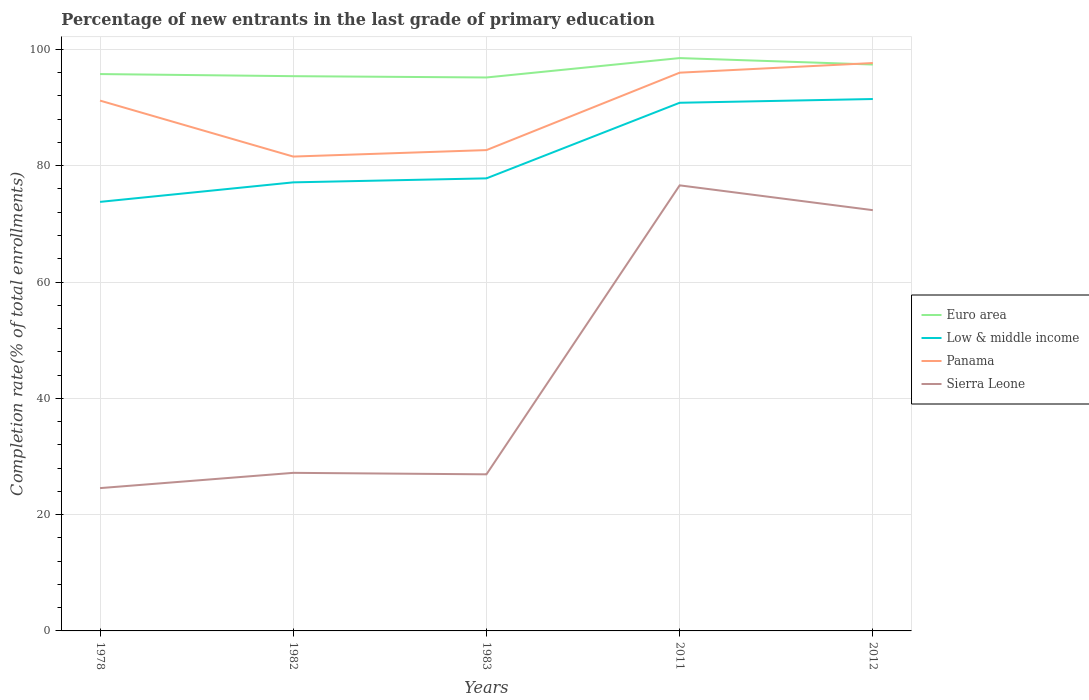Does the line corresponding to Euro area intersect with the line corresponding to Panama?
Your answer should be compact. Yes. Is the number of lines equal to the number of legend labels?
Your response must be concise. Yes. Across all years, what is the maximum percentage of new entrants in Low & middle income?
Offer a terse response. 73.78. What is the total percentage of new entrants in Panama in the graph?
Give a very brief answer. -1.11. What is the difference between the highest and the second highest percentage of new entrants in Euro area?
Give a very brief answer. 3.33. Is the percentage of new entrants in Panama strictly greater than the percentage of new entrants in Euro area over the years?
Offer a very short reply. No. How many years are there in the graph?
Your answer should be very brief. 5. Does the graph contain any zero values?
Your answer should be compact. No. Does the graph contain grids?
Offer a terse response. Yes. What is the title of the graph?
Your answer should be compact. Percentage of new entrants in the last grade of primary education. Does "Congo (Republic)" appear as one of the legend labels in the graph?
Give a very brief answer. No. What is the label or title of the Y-axis?
Make the answer very short. Completion rate(% of total enrollments). What is the Completion rate(% of total enrollments) of Euro area in 1978?
Provide a short and direct response. 95.76. What is the Completion rate(% of total enrollments) of Low & middle income in 1978?
Make the answer very short. 73.78. What is the Completion rate(% of total enrollments) in Panama in 1978?
Your answer should be very brief. 91.2. What is the Completion rate(% of total enrollments) of Sierra Leone in 1978?
Make the answer very short. 24.56. What is the Completion rate(% of total enrollments) of Euro area in 1982?
Keep it short and to the point. 95.4. What is the Completion rate(% of total enrollments) of Low & middle income in 1982?
Keep it short and to the point. 77.14. What is the Completion rate(% of total enrollments) in Panama in 1982?
Provide a short and direct response. 81.57. What is the Completion rate(% of total enrollments) of Sierra Leone in 1982?
Your response must be concise. 27.18. What is the Completion rate(% of total enrollments) of Euro area in 1983?
Ensure brevity in your answer.  95.17. What is the Completion rate(% of total enrollments) of Low & middle income in 1983?
Your response must be concise. 77.83. What is the Completion rate(% of total enrollments) in Panama in 1983?
Keep it short and to the point. 82.69. What is the Completion rate(% of total enrollments) in Sierra Leone in 1983?
Your answer should be very brief. 26.93. What is the Completion rate(% of total enrollments) in Euro area in 2011?
Give a very brief answer. 98.51. What is the Completion rate(% of total enrollments) in Low & middle income in 2011?
Make the answer very short. 90.82. What is the Completion rate(% of total enrollments) of Panama in 2011?
Ensure brevity in your answer.  96. What is the Completion rate(% of total enrollments) in Sierra Leone in 2011?
Your answer should be very brief. 76.62. What is the Completion rate(% of total enrollments) in Euro area in 2012?
Your answer should be very brief. 97.4. What is the Completion rate(% of total enrollments) of Low & middle income in 2012?
Your answer should be very brief. 91.47. What is the Completion rate(% of total enrollments) in Panama in 2012?
Provide a short and direct response. 97.66. What is the Completion rate(% of total enrollments) of Sierra Leone in 2012?
Ensure brevity in your answer.  72.36. Across all years, what is the maximum Completion rate(% of total enrollments) in Euro area?
Offer a very short reply. 98.51. Across all years, what is the maximum Completion rate(% of total enrollments) in Low & middle income?
Offer a terse response. 91.47. Across all years, what is the maximum Completion rate(% of total enrollments) in Panama?
Your answer should be compact. 97.66. Across all years, what is the maximum Completion rate(% of total enrollments) of Sierra Leone?
Give a very brief answer. 76.62. Across all years, what is the minimum Completion rate(% of total enrollments) of Euro area?
Ensure brevity in your answer.  95.17. Across all years, what is the minimum Completion rate(% of total enrollments) of Low & middle income?
Provide a short and direct response. 73.78. Across all years, what is the minimum Completion rate(% of total enrollments) in Panama?
Offer a terse response. 81.57. Across all years, what is the minimum Completion rate(% of total enrollments) in Sierra Leone?
Keep it short and to the point. 24.56. What is the total Completion rate(% of total enrollments) of Euro area in the graph?
Your response must be concise. 482.24. What is the total Completion rate(% of total enrollments) of Low & middle income in the graph?
Your answer should be compact. 411.04. What is the total Completion rate(% of total enrollments) of Panama in the graph?
Your answer should be compact. 449.11. What is the total Completion rate(% of total enrollments) in Sierra Leone in the graph?
Provide a succinct answer. 227.65. What is the difference between the Completion rate(% of total enrollments) in Euro area in 1978 and that in 1982?
Provide a succinct answer. 0.36. What is the difference between the Completion rate(% of total enrollments) in Low & middle income in 1978 and that in 1982?
Ensure brevity in your answer.  -3.36. What is the difference between the Completion rate(% of total enrollments) of Panama in 1978 and that in 1982?
Ensure brevity in your answer.  9.62. What is the difference between the Completion rate(% of total enrollments) of Sierra Leone in 1978 and that in 1982?
Make the answer very short. -2.63. What is the difference between the Completion rate(% of total enrollments) in Euro area in 1978 and that in 1983?
Give a very brief answer. 0.58. What is the difference between the Completion rate(% of total enrollments) in Low & middle income in 1978 and that in 1983?
Keep it short and to the point. -4.04. What is the difference between the Completion rate(% of total enrollments) in Panama in 1978 and that in 1983?
Offer a terse response. 8.51. What is the difference between the Completion rate(% of total enrollments) of Sierra Leone in 1978 and that in 1983?
Provide a short and direct response. -2.37. What is the difference between the Completion rate(% of total enrollments) in Euro area in 1978 and that in 2011?
Your answer should be compact. -2.75. What is the difference between the Completion rate(% of total enrollments) in Low & middle income in 1978 and that in 2011?
Offer a very short reply. -17.04. What is the difference between the Completion rate(% of total enrollments) in Panama in 1978 and that in 2011?
Ensure brevity in your answer.  -4.8. What is the difference between the Completion rate(% of total enrollments) in Sierra Leone in 1978 and that in 2011?
Make the answer very short. -52.06. What is the difference between the Completion rate(% of total enrollments) of Euro area in 1978 and that in 2012?
Your answer should be compact. -1.64. What is the difference between the Completion rate(% of total enrollments) of Low & middle income in 1978 and that in 2012?
Offer a very short reply. -17.69. What is the difference between the Completion rate(% of total enrollments) in Panama in 1978 and that in 2012?
Make the answer very short. -6.46. What is the difference between the Completion rate(% of total enrollments) in Sierra Leone in 1978 and that in 2012?
Your answer should be compact. -47.8. What is the difference between the Completion rate(% of total enrollments) in Euro area in 1982 and that in 1983?
Your response must be concise. 0.22. What is the difference between the Completion rate(% of total enrollments) in Low & middle income in 1982 and that in 1983?
Keep it short and to the point. -0.69. What is the difference between the Completion rate(% of total enrollments) in Panama in 1982 and that in 1983?
Ensure brevity in your answer.  -1.11. What is the difference between the Completion rate(% of total enrollments) in Sierra Leone in 1982 and that in 1983?
Ensure brevity in your answer.  0.26. What is the difference between the Completion rate(% of total enrollments) in Euro area in 1982 and that in 2011?
Your answer should be compact. -3.11. What is the difference between the Completion rate(% of total enrollments) of Low & middle income in 1982 and that in 2011?
Provide a succinct answer. -13.69. What is the difference between the Completion rate(% of total enrollments) of Panama in 1982 and that in 2011?
Your answer should be very brief. -14.43. What is the difference between the Completion rate(% of total enrollments) of Sierra Leone in 1982 and that in 2011?
Your answer should be very brief. -49.44. What is the difference between the Completion rate(% of total enrollments) in Euro area in 1982 and that in 2012?
Keep it short and to the point. -2. What is the difference between the Completion rate(% of total enrollments) in Low & middle income in 1982 and that in 2012?
Your answer should be compact. -14.33. What is the difference between the Completion rate(% of total enrollments) of Panama in 1982 and that in 2012?
Offer a very short reply. -16.08. What is the difference between the Completion rate(% of total enrollments) of Sierra Leone in 1982 and that in 2012?
Make the answer very short. -45.17. What is the difference between the Completion rate(% of total enrollments) in Euro area in 1983 and that in 2011?
Your answer should be compact. -3.33. What is the difference between the Completion rate(% of total enrollments) of Low & middle income in 1983 and that in 2011?
Your answer should be very brief. -13. What is the difference between the Completion rate(% of total enrollments) of Panama in 1983 and that in 2011?
Provide a succinct answer. -13.31. What is the difference between the Completion rate(% of total enrollments) of Sierra Leone in 1983 and that in 2011?
Give a very brief answer. -49.69. What is the difference between the Completion rate(% of total enrollments) in Euro area in 1983 and that in 2012?
Ensure brevity in your answer.  -2.23. What is the difference between the Completion rate(% of total enrollments) in Low & middle income in 1983 and that in 2012?
Your response must be concise. -13.64. What is the difference between the Completion rate(% of total enrollments) of Panama in 1983 and that in 2012?
Give a very brief answer. -14.97. What is the difference between the Completion rate(% of total enrollments) of Sierra Leone in 1983 and that in 2012?
Offer a very short reply. -45.43. What is the difference between the Completion rate(% of total enrollments) in Euro area in 2011 and that in 2012?
Your answer should be compact. 1.11. What is the difference between the Completion rate(% of total enrollments) in Low & middle income in 2011 and that in 2012?
Provide a succinct answer. -0.64. What is the difference between the Completion rate(% of total enrollments) of Panama in 2011 and that in 2012?
Your answer should be very brief. -1.66. What is the difference between the Completion rate(% of total enrollments) in Sierra Leone in 2011 and that in 2012?
Offer a very short reply. 4.27. What is the difference between the Completion rate(% of total enrollments) in Euro area in 1978 and the Completion rate(% of total enrollments) in Low & middle income in 1982?
Your answer should be very brief. 18.62. What is the difference between the Completion rate(% of total enrollments) of Euro area in 1978 and the Completion rate(% of total enrollments) of Panama in 1982?
Ensure brevity in your answer.  14.19. What is the difference between the Completion rate(% of total enrollments) of Euro area in 1978 and the Completion rate(% of total enrollments) of Sierra Leone in 1982?
Your response must be concise. 68.58. What is the difference between the Completion rate(% of total enrollments) in Low & middle income in 1978 and the Completion rate(% of total enrollments) in Panama in 1982?
Ensure brevity in your answer.  -7.79. What is the difference between the Completion rate(% of total enrollments) of Low & middle income in 1978 and the Completion rate(% of total enrollments) of Sierra Leone in 1982?
Your answer should be compact. 46.6. What is the difference between the Completion rate(% of total enrollments) of Panama in 1978 and the Completion rate(% of total enrollments) of Sierra Leone in 1982?
Provide a short and direct response. 64.01. What is the difference between the Completion rate(% of total enrollments) of Euro area in 1978 and the Completion rate(% of total enrollments) of Low & middle income in 1983?
Keep it short and to the point. 17.93. What is the difference between the Completion rate(% of total enrollments) of Euro area in 1978 and the Completion rate(% of total enrollments) of Panama in 1983?
Keep it short and to the point. 13.07. What is the difference between the Completion rate(% of total enrollments) of Euro area in 1978 and the Completion rate(% of total enrollments) of Sierra Leone in 1983?
Keep it short and to the point. 68.83. What is the difference between the Completion rate(% of total enrollments) of Low & middle income in 1978 and the Completion rate(% of total enrollments) of Panama in 1983?
Ensure brevity in your answer.  -8.9. What is the difference between the Completion rate(% of total enrollments) in Low & middle income in 1978 and the Completion rate(% of total enrollments) in Sierra Leone in 1983?
Ensure brevity in your answer.  46.85. What is the difference between the Completion rate(% of total enrollments) of Panama in 1978 and the Completion rate(% of total enrollments) of Sierra Leone in 1983?
Your response must be concise. 64.27. What is the difference between the Completion rate(% of total enrollments) of Euro area in 1978 and the Completion rate(% of total enrollments) of Low & middle income in 2011?
Give a very brief answer. 4.93. What is the difference between the Completion rate(% of total enrollments) in Euro area in 1978 and the Completion rate(% of total enrollments) in Panama in 2011?
Provide a succinct answer. -0.24. What is the difference between the Completion rate(% of total enrollments) in Euro area in 1978 and the Completion rate(% of total enrollments) in Sierra Leone in 2011?
Your response must be concise. 19.14. What is the difference between the Completion rate(% of total enrollments) in Low & middle income in 1978 and the Completion rate(% of total enrollments) in Panama in 2011?
Provide a succinct answer. -22.22. What is the difference between the Completion rate(% of total enrollments) in Low & middle income in 1978 and the Completion rate(% of total enrollments) in Sierra Leone in 2011?
Your answer should be very brief. -2.84. What is the difference between the Completion rate(% of total enrollments) of Panama in 1978 and the Completion rate(% of total enrollments) of Sierra Leone in 2011?
Your response must be concise. 14.57. What is the difference between the Completion rate(% of total enrollments) of Euro area in 1978 and the Completion rate(% of total enrollments) of Low & middle income in 2012?
Provide a short and direct response. 4.29. What is the difference between the Completion rate(% of total enrollments) in Euro area in 1978 and the Completion rate(% of total enrollments) in Panama in 2012?
Offer a terse response. -1.9. What is the difference between the Completion rate(% of total enrollments) of Euro area in 1978 and the Completion rate(% of total enrollments) of Sierra Leone in 2012?
Your response must be concise. 23.4. What is the difference between the Completion rate(% of total enrollments) in Low & middle income in 1978 and the Completion rate(% of total enrollments) in Panama in 2012?
Provide a short and direct response. -23.88. What is the difference between the Completion rate(% of total enrollments) in Low & middle income in 1978 and the Completion rate(% of total enrollments) in Sierra Leone in 2012?
Give a very brief answer. 1.42. What is the difference between the Completion rate(% of total enrollments) of Panama in 1978 and the Completion rate(% of total enrollments) of Sierra Leone in 2012?
Offer a very short reply. 18.84. What is the difference between the Completion rate(% of total enrollments) in Euro area in 1982 and the Completion rate(% of total enrollments) in Low & middle income in 1983?
Give a very brief answer. 17.57. What is the difference between the Completion rate(% of total enrollments) of Euro area in 1982 and the Completion rate(% of total enrollments) of Panama in 1983?
Provide a succinct answer. 12.71. What is the difference between the Completion rate(% of total enrollments) of Euro area in 1982 and the Completion rate(% of total enrollments) of Sierra Leone in 1983?
Offer a very short reply. 68.47. What is the difference between the Completion rate(% of total enrollments) in Low & middle income in 1982 and the Completion rate(% of total enrollments) in Panama in 1983?
Your answer should be very brief. -5.55. What is the difference between the Completion rate(% of total enrollments) in Low & middle income in 1982 and the Completion rate(% of total enrollments) in Sierra Leone in 1983?
Your answer should be compact. 50.21. What is the difference between the Completion rate(% of total enrollments) of Panama in 1982 and the Completion rate(% of total enrollments) of Sierra Leone in 1983?
Your answer should be very brief. 54.64. What is the difference between the Completion rate(% of total enrollments) of Euro area in 1982 and the Completion rate(% of total enrollments) of Low & middle income in 2011?
Keep it short and to the point. 4.57. What is the difference between the Completion rate(% of total enrollments) in Euro area in 1982 and the Completion rate(% of total enrollments) in Panama in 2011?
Offer a very short reply. -0.6. What is the difference between the Completion rate(% of total enrollments) of Euro area in 1982 and the Completion rate(% of total enrollments) of Sierra Leone in 2011?
Your answer should be compact. 18.78. What is the difference between the Completion rate(% of total enrollments) in Low & middle income in 1982 and the Completion rate(% of total enrollments) in Panama in 2011?
Provide a short and direct response. -18.86. What is the difference between the Completion rate(% of total enrollments) in Low & middle income in 1982 and the Completion rate(% of total enrollments) in Sierra Leone in 2011?
Offer a very short reply. 0.52. What is the difference between the Completion rate(% of total enrollments) of Panama in 1982 and the Completion rate(% of total enrollments) of Sierra Leone in 2011?
Make the answer very short. 4.95. What is the difference between the Completion rate(% of total enrollments) of Euro area in 1982 and the Completion rate(% of total enrollments) of Low & middle income in 2012?
Offer a very short reply. 3.93. What is the difference between the Completion rate(% of total enrollments) in Euro area in 1982 and the Completion rate(% of total enrollments) in Panama in 2012?
Your answer should be compact. -2.26. What is the difference between the Completion rate(% of total enrollments) of Euro area in 1982 and the Completion rate(% of total enrollments) of Sierra Leone in 2012?
Your answer should be very brief. 23.04. What is the difference between the Completion rate(% of total enrollments) of Low & middle income in 1982 and the Completion rate(% of total enrollments) of Panama in 2012?
Your answer should be very brief. -20.52. What is the difference between the Completion rate(% of total enrollments) of Low & middle income in 1982 and the Completion rate(% of total enrollments) of Sierra Leone in 2012?
Offer a very short reply. 4.78. What is the difference between the Completion rate(% of total enrollments) of Panama in 1982 and the Completion rate(% of total enrollments) of Sierra Leone in 2012?
Your response must be concise. 9.22. What is the difference between the Completion rate(% of total enrollments) in Euro area in 1983 and the Completion rate(% of total enrollments) in Low & middle income in 2011?
Your response must be concise. 4.35. What is the difference between the Completion rate(% of total enrollments) in Euro area in 1983 and the Completion rate(% of total enrollments) in Panama in 2011?
Ensure brevity in your answer.  -0.82. What is the difference between the Completion rate(% of total enrollments) in Euro area in 1983 and the Completion rate(% of total enrollments) in Sierra Leone in 2011?
Offer a terse response. 18.55. What is the difference between the Completion rate(% of total enrollments) in Low & middle income in 1983 and the Completion rate(% of total enrollments) in Panama in 2011?
Your response must be concise. -18.17. What is the difference between the Completion rate(% of total enrollments) in Low & middle income in 1983 and the Completion rate(% of total enrollments) in Sierra Leone in 2011?
Your response must be concise. 1.2. What is the difference between the Completion rate(% of total enrollments) of Panama in 1983 and the Completion rate(% of total enrollments) of Sierra Leone in 2011?
Keep it short and to the point. 6.06. What is the difference between the Completion rate(% of total enrollments) in Euro area in 1983 and the Completion rate(% of total enrollments) in Low & middle income in 2012?
Keep it short and to the point. 3.71. What is the difference between the Completion rate(% of total enrollments) in Euro area in 1983 and the Completion rate(% of total enrollments) in Panama in 2012?
Your answer should be very brief. -2.48. What is the difference between the Completion rate(% of total enrollments) in Euro area in 1983 and the Completion rate(% of total enrollments) in Sierra Leone in 2012?
Your answer should be very brief. 22.82. What is the difference between the Completion rate(% of total enrollments) of Low & middle income in 1983 and the Completion rate(% of total enrollments) of Panama in 2012?
Offer a very short reply. -19.83. What is the difference between the Completion rate(% of total enrollments) of Low & middle income in 1983 and the Completion rate(% of total enrollments) of Sierra Leone in 2012?
Offer a very short reply. 5.47. What is the difference between the Completion rate(% of total enrollments) of Panama in 1983 and the Completion rate(% of total enrollments) of Sierra Leone in 2012?
Keep it short and to the point. 10.33. What is the difference between the Completion rate(% of total enrollments) of Euro area in 2011 and the Completion rate(% of total enrollments) of Low & middle income in 2012?
Offer a very short reply. 7.04. What is the difference between the Completion rate(% of total enrollments) of Euro area in 2011 and the Completion rate(% of total enrollments) of Panama in 2012?
Offer a terse response. 0.85. What is the difference between the Completion rate(% of total enrollments) of Euro area in 2011 and the Completion rate(% of total enrollments) of Sierra Leone in 2012?
Your response must be concise. 26.15. What is the difference between the Completion rate(% of total enrollments) of Low & middle income in 2011 and the Completion rate(% of total enrollments) of Panama in 2012?
Make the answer very short. -6.83. What is the difference between the Completion rate(% of total enrollments) of Low & middle income in 2011 and the Completion rate(% of total enrollments) of Sierra Leone in 2012?
Offer a very short reply. 18.47. What is the difference between the Completion rate(% of total enrollments) in Panama in 2011 and the Completion rate(% of total enrollments) in Sierra Leone in 2012?
Ensure brevity in your answer.  23.64. What is the average Completion rate(% of total enrollments) in Euro area per year?
Provide a succinct answer. 96.45. What is the average Completion rate(% of total enrollments) of Low & middle income per year?
Provide a succinct answer. 82.21. What is the average Completion rate(% of total enrollments) of Panama per year?
Give a very brief answer. 89.82. What is the average Completion rate(% of total enrollments) of Sierra Leone per year?
Offer a terse response. 45.53. In the year 1978, what is the difference between the Completion rate(% of total enrollments) of Euro area and Completion rate(% of total enrollments) of Low & middle income?
Your answer should be very brief. 21.98. In the year 1978, what is the difference between the Completion rate(% of total enrollments) in Euro area and Completion rate(% of total enrollments) in Panama?
Ensure brevity in your answer.  4.56. In the year 1978, what is the difference between the Completion rate(% of total enrollments) of Euro area and Completion rate(% of total enrollments) of Sierra Leone?
Ensure brevity in your answer.  71.2. In the year 1978, what is the difference between the Completion rate(% of total enrollments) in Low & middle income and Completion rate(% of total enrollments) in Panama?
Provide a short and direct response. -17.42. In the year 1978, what is the difference between the Completion rate(% of total enrollments) in Low & middle income and Completion rate(% of total enrollments) in Sierra Leone?
Offer a very short reply. 49.22. In the year 1978, what is the difference between the Completion rate(% of total enrollments) of Panama and Completion rate(% of total enrollments) of Sierra Leone?
Your answer should be very brief. 66.64. In the year 1982, what is the difference between the Completion rate(% of total enrollments) in Euro area and Completion rate(% of total enrollments) in Low & middle income?
Make the answer very short. 18.26. In the year 1982, what is the difference between the Completion rate(% of total enrollments) in Euro area and Completion rate(% of total enrollments) in Panama?
Provide a short and direct response. 13.83. In the year 1982, what is the difference between the Completion rate(% of total enrollments) in Euro area and Completion rate(% of total enrollments) in Sierra Leone?
Give a very brief answer. 68.21. In the year 1982, what is the difference between the Completion rate(% of total enrollments) of Low & middle income and Completion rate(% of total enrollments) of Panama?
Offer a terse response. -4.44. In the year 1982, what is the difference between the Completion rate(% of total enrollments) in Low & middle income and Completion rate(% of total enrollments) in Sierra Leone?
Ensure brevity in your answer.  49.95. In the year 1982, what is the difference between the Completion rate(% of total enrollments) in Panama and Completion rate(% of total enrollments) in Sierra Leone?
Keep it short and to the point. 54.39. In the year 1983, what is the difference between the Completion rate(% of total enrollments) of Euro area and Completion rate(% of total enrollments) of Low & middle income?
Give a very brief answer. 17.35. In the year 1983, what is the difference between the Completion rate(% of total enrollments) in Euro area and Completion rate(% of total enrollments) in Panama?
Give a very brief answer. 12.49. In the year 1983, what is the difference between the Completion rate(% of total enrollments) of Euro area and Completion rate(% of total enrollments) of Sierra Leone?
Your response must be concise. 68.25. In the year 1983, what is the difference between the Completion rate(% of total enrollments) in Low & middle income and Completion rate(% of total enrollments) in Panama?
Give a very brief answer. -4.86. In the year 1983, what is the difference between the Completion rate(% of total enrollments) of Low & middle income and Completion rate(% of total enrollments) of Sierra Leone?
Your answer should be very brief. 50.9. In the year 1983, what is the difference between the Completion rate(% of total enrollments) in Panama and Completion rate(% of total enrollments) in Sierra Leone?
Your answer should be compact. 55.76. In the year 2011, what is the difference between the Completion rate(% of total enrollments) of Euro area and Completion rate(% of total enrollments) of Low & middle income?
Give a very brief answer. 7.68. In the year 2011, what is the difference between the Completion rate(% of total enrollments) of Euro area and Completion rate(% of total enrollments) of Panama?
Keep it short and to the point. 2.51. In the year 2011, what is the difference between the Completion rate(% of total enrollments) of Euro area and Completion rate(% of total enrollments) of Sierra Leone?
Your response must be concise. 21.89. In the year 2011, what is the difference between the Completion rate(% of total enrollments) of Low & middle income and Completion rate(% of total enrollments) of Panama?
Give a very brief answer. -5.17. In the year 2011, what is the difference between the Completion rate(% of total enrollments) of Low & middle income and Completion rate(% of total enrollments) of Sierra Leone?
Provide a short and direct response. 14.2. In the year 2011, what is the difference between the Completion rate(% of total enrollments) in Panama and Completion rate(% of total enrollments) in Sierra Leone?
Provide a short and direct response. 19.38. In the year 2012, what is the difference between the Completion rate(% of total enrollments) of Euro area and Completion rate(% of total enrollments) of Low & middle income?
Your answer should be very brief. 5.93. In the year 2012, what is the difference between the Completion rate(% of total enrollments) in Euro area and Completion rate(% of total enrollments) in Panama?
Provide a succinct answer. -0.26. In the year 2012, what is the difference between the Completion rate(% of total enrollments) of Euro area and Completion rate(% of total enrollments) of Sierra Leone?
Keep it short and to the point. 25.04. In the year 2012, what is the difference between the Completion rate(% of total enrollments) of Low & middle income and Completion rate(% of total enrollments) of Panama?
Keep it short and to the point. -6.19. In the year 2012, what is the difference between the Completion rate(% of total enrollments) in Low & middle income and Completion rate(% of total enrollments) in Sierra Leone?
Provide a short and direct response. 19.11. In the year 2012, what is the difference between the Completion rate(% of total enrollments) in Panama and Completion rate(% of total enrollments) in Sierra Leone?
Give a very brief answer. 25.3. What is the ratio of the Completion rate(% of total enrollments) of Low & middle income in 1978 to that in 1982?
Offer a very short reply. 0.96. What is the ratio of the Completion rate(% of total enrollments) of Panama in 1978 to that in 1982?
Give a very brief answer. 1.12. What is the ratio of the Completion rate(% of total enrollments) in Sierra Leone in 1978 to that in 1982?
Ensure brevity in your answer.  0.9. What is the ratio of the Completion rate(% of total enrollments) of Euro area in 1978 to that in 1983?
Keep it short and to the point. 1.01. What is the ratio of the Completion rate(% of total enrollments) in Low & middle income in 1978 to that in 1983?
Your response must be concise. 0.95. What is the ratio of the Completion rate(% of total enrollments) in Panama in 1978 to that in 1983?
Keep it short and to the point. 1.1. What is the ratio of the Completion rate(% of total enrollments) in Sierra Leone in 1978 to that in 1983?
Provide a short and direct response. 0.91. What is the ratio of the Completion rate(% of total enrollments) in Euro area in 1978 to that in 2011?
Your answer should be compact. 0.97. What is the ratio of the Completion rate(% of total enrollments) of Low & middle income in 1978 to that in 2011?
Ensure brevity in your answer.  0.81. What is the ratio of the Completion rate(% of total enrollments) of Panama in 1978 to that in 2011?
Give a very brief answer. 0.95. What is the ratio of the Completion rate(% of total enrollments) of Sierra Leone in 1978 to that in 2011?
Provide a succinct answer. 0.32. What is the ratio of the Completion rate(% of total enrollments) in Euro area in 1978 to that in 2012?
Give a very brief answer. 0.98. What is the ratio of the Completion rate(% of total enrollments) in Low & middle income in 1978 to that in 2012?
Provide a succinct answer. 0.81. What is the ratio of the Completion rate(% of total enrollments) in Panama in 1978 to that in 2012?
Your answer should be very brief. 0.93. What is the ratio of the Completion rate(% of total enrollments) in Sierra Leone in 1978 to that in 2012?
Give a very brief answer. 0.34. What is the ratio of the Completion rate(% of total enrollments) of Euro area in 1982 to that in 1983?
Keep it short and to the point. 1. What is the ratio of the Completion rate(% of total enrollments) of Panama in 1982 to that in 1983?
Make the answer very short. 0.99. What is the ratio of the Completion rate(% of total enrollments) in Sierra Leone in 1982 to that in 1983?
Provide a short and direct response. 1.01. What is the ratio of the Completion rate(% of total enrollments) in Euro area in 1982 to that in 2011?
Make the answer very short. 0.97. What is the ratio of the Completion rate(% of total enrollments) in Low & middle income in 1982 to that in 2011?
Offer a very short reply. 0.85. What is the ratio of the Completion rate(% of total enrollments) in Panama in 1982 to that in 2011?
Give a very brief answer. 0.85. What is the ratio of the Completion rate(% of total enrollments) of Sierra Leone in 1982 to that in 2011?
Provide a succinct answer. 0.35. What is the ratio of the Completion rate(% of total enrollments) in Euro area in 1982 to that in 2012?
Your answer should be compact. 0.98. What is the ratio of the Completion rate(% of total enrollments) of Low & middle income in 1982 to that in 2012?
Ensure brevity in your answer.  0.84. What is the ratio of the Completion rate(% of total enrollments) in Panama in 1982 to that in 2012?
Offer a terse response. 0.84. What is the ratio of the Completion rate(% of total enrollments) in Sierra Leone in 1982 to that in 2012?
Your answer should be very brief. 0.38. What is the ratio of the Completion rate(% of total enrollments) of Euro area in 1983 to that in 2011?
Offer a terse response. 0.97. What is the ratio of the Completion rate(% of total enrollments) of Low & middle income in 1983 to that in 2011?
Provide a succinct answer. 0.86. What is the ratio of the Completion rate(% of total enrollments) in Panama in 1983 to that in 2011?
Your answer should be very brief. 0.86. What is the ratio of the Completion rate(% of total enrollments) of Sierra Leone in 1983 to that in 2011?
Your answer should be very brief. 0.35. What is the ratio of the Completion rate(% of total enrollments) of Euro area in 1983 to that in 2012?
Offer a very short reply. 0.98. What is the ratio of the Completion rate(% of total enrollments) in Low & middle income in 1983 to that in 2012?
Your response must be concise. 0.85. What is the ratio of the Completion rate(% of total enrollments) in Panama in 1983 to that in 2012?
Your answer should be compact. 0.85. What is the ratio of the Completion rate(% of total enrollments) in Sierra Leone in 1983 to that in 2012?
Your response must be concise. 0.37. What is the ratio of the Completion rate(% of total enrollments) of Euro area in 2011 to that in 2012?
Provide a succinct answer. 1.01. What is the ratio of the Completion rate(% of total enrollments) of Sierra Leone in 2011 to that in 2012?
Your response must be concise. 1.06. What is the difference between the highest and the second highest Completion rate(% of total enrollments) in Euro area?
Provide a succinct answer. 1.11. What is the difference between the highest and the second highest Completion rate(% of total enrollments) of Low & middle income?
Provide a short and direct response. 0.64. What is the difference between the highest and the second highest Completion rate(% of total enrollments) of Panama?
Offer a very short reply. 1.66. What is the difference between the highest and the second highest Completion rate(% of total enrollments) in Sierra Leone?
Provide a succinct answer. 4.27. What is the difference between the highest and the lowest Completion rate(% of total enrollments) of Euro area?
Your response must be concise. 3.33. What is the difference between the highest and the lowest Completion rate(% of total enrollments) in Low & middle income?
Your answer should be compact. 17.69. What is the difference between the highest and the lowest Completion rate(% of total enrollments) in Panama?
Offer a terse response. 16.08. What is the difference between the highest and the lowest Completion rate(% of total enrollments) of Sierra Leone?
Make the answer very short. 52.06. 